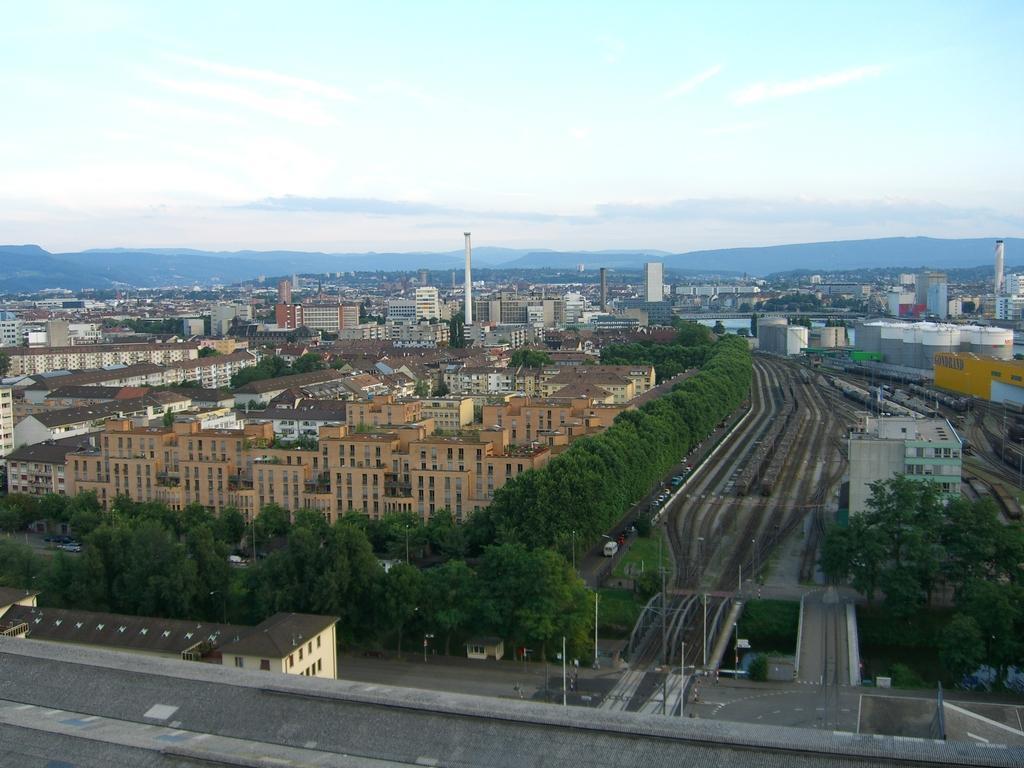Could you give a brief overview of what you see in this image? In this picture there is a top view of the city full of many buildings and trees. In the middle there is a road. On the right side we can see some houses and Industrial area. Behind we can see the mountains and above there is a sky and clouds. 